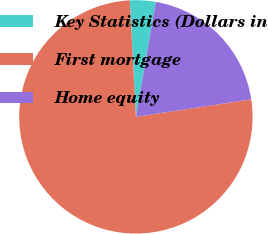Convert chart to OTSL. <chart><loc_0><loc_0><loc_500><loc_500><pie_chart><fcel>Key Statistics (Dollars in<fcel>First mortgage<fcel>Home equity<nl><fcel>3.56%<fcel>76.57%<fcel>19.87%<nl></chart> 